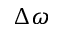<formula> <loc_0><loc_0><loc_500><loc_500>\Delta \omega</formula> 